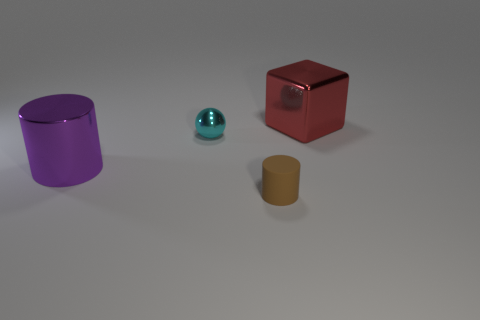What number of yellow objects are either metallic spheres or large cubes?
Give a very brief answer. 0. What is the size of the red thing that is the same material as the sphere?
Your answer should be very brief. Large. Is the material of the cylinder on the right side of the large purple object the same as the small thing behind the small brown cylinder?
Offer a very short reply. No. What number of cubes are tiny blue rubber objects or red metal things?
Your answer should be compact. 1. How many large purple cylinders are in front of the big metallic object that is right of the big metallic thing in front of the red thing?
Provide a succinct answer. 1. There is a small thing that is the same shape as the big purple metallic object; what is its material?
Provide a short and direct response. Rubber. Are there any other things that are the same material as the purple cylinder?
Give a very brief answer. Yes. There is a small object that is in front of the purple metallic cylinder; what color is it?
Your answer should be compact. Brown. Does the red thing have the same material as the large thing that is to the left of the big shiny block?
Offer a terse response. Yes. What material is the big purple object?
Offer a very short reply. Metal. 